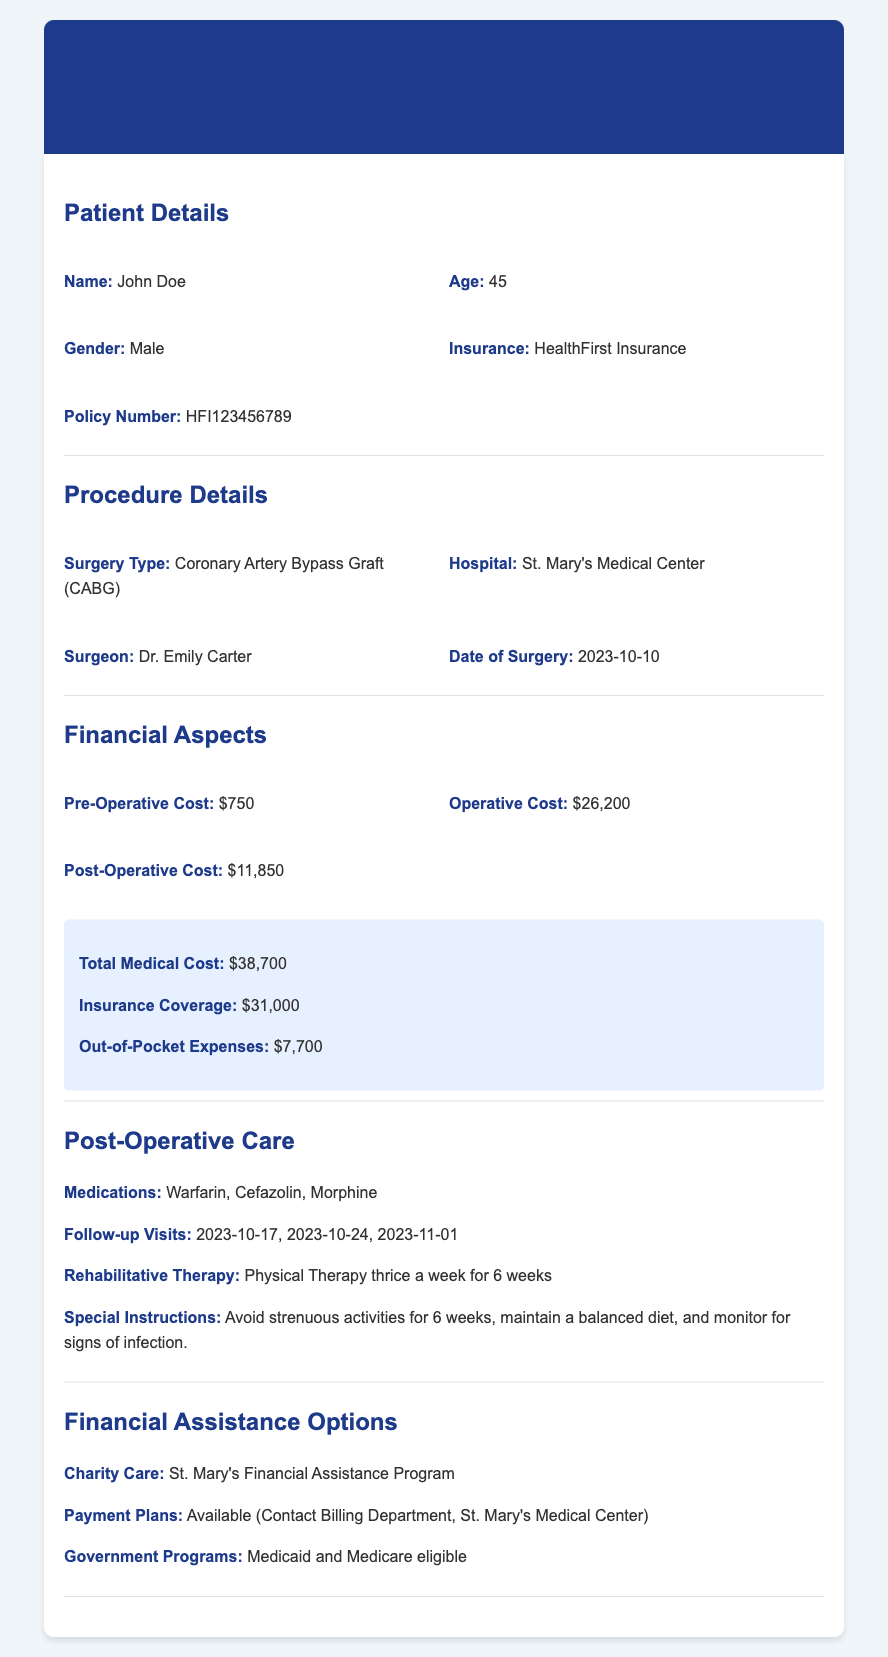What is the name of the patient? The document lists the patient's name as John Doe.
Answer: John Doe What type of surgery did the patient undergo? The procedure section states the surgery type is Coronary Artery Bypass Graft (CABG).
Answer: Coronary Artery Bypass Graft (CABG) What is the date of surgery? The document specifies the date of surgery as 2023-10-10.
Answer: 2023-10-10 What is the operative cost of the surgery? The financial aspects outline the operative cost as $26,200.
Answer: $26,200 What are the total medical costs incurred by the patient? The document lists the total medical cost as $38,700.
Answer: $38,700 What are the post-operative medications prescribed? The post-operative care section includes Warfarin, Cefazolin, and Morphine as medications.
Answer: Warfarin, Cefazolin, Morphine What is the patient's total out-of-pocket expense? The financial aspects show the out-of-pocket expenses amount to $7,700.
Answer: $7,700 What financial assistance program is mentioned? The financial assistance options section refers to St. Mary's Financial Assistance Program.
Answer: St. Mary's Financial Assistance Program How many follow-up visits are scheduled? The follow-up visits section lists three dates for follow-up visits.
Answer: Three dates 